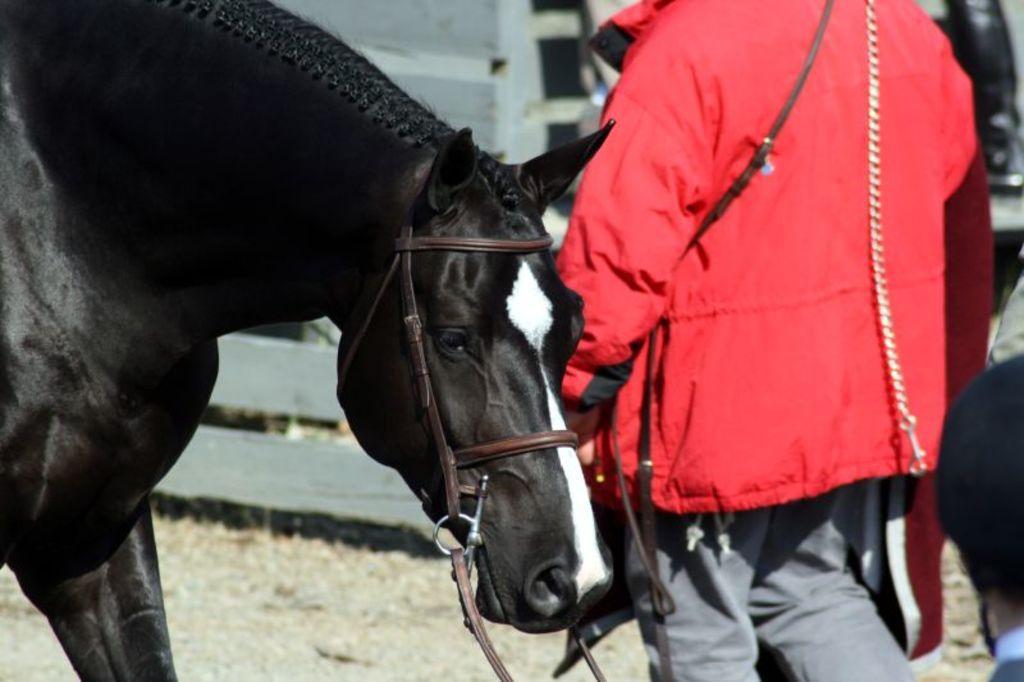How would you summarize this image in a sentence or two? In this picture there is a black horse and there is a man with red jacket standing behind the horse. 